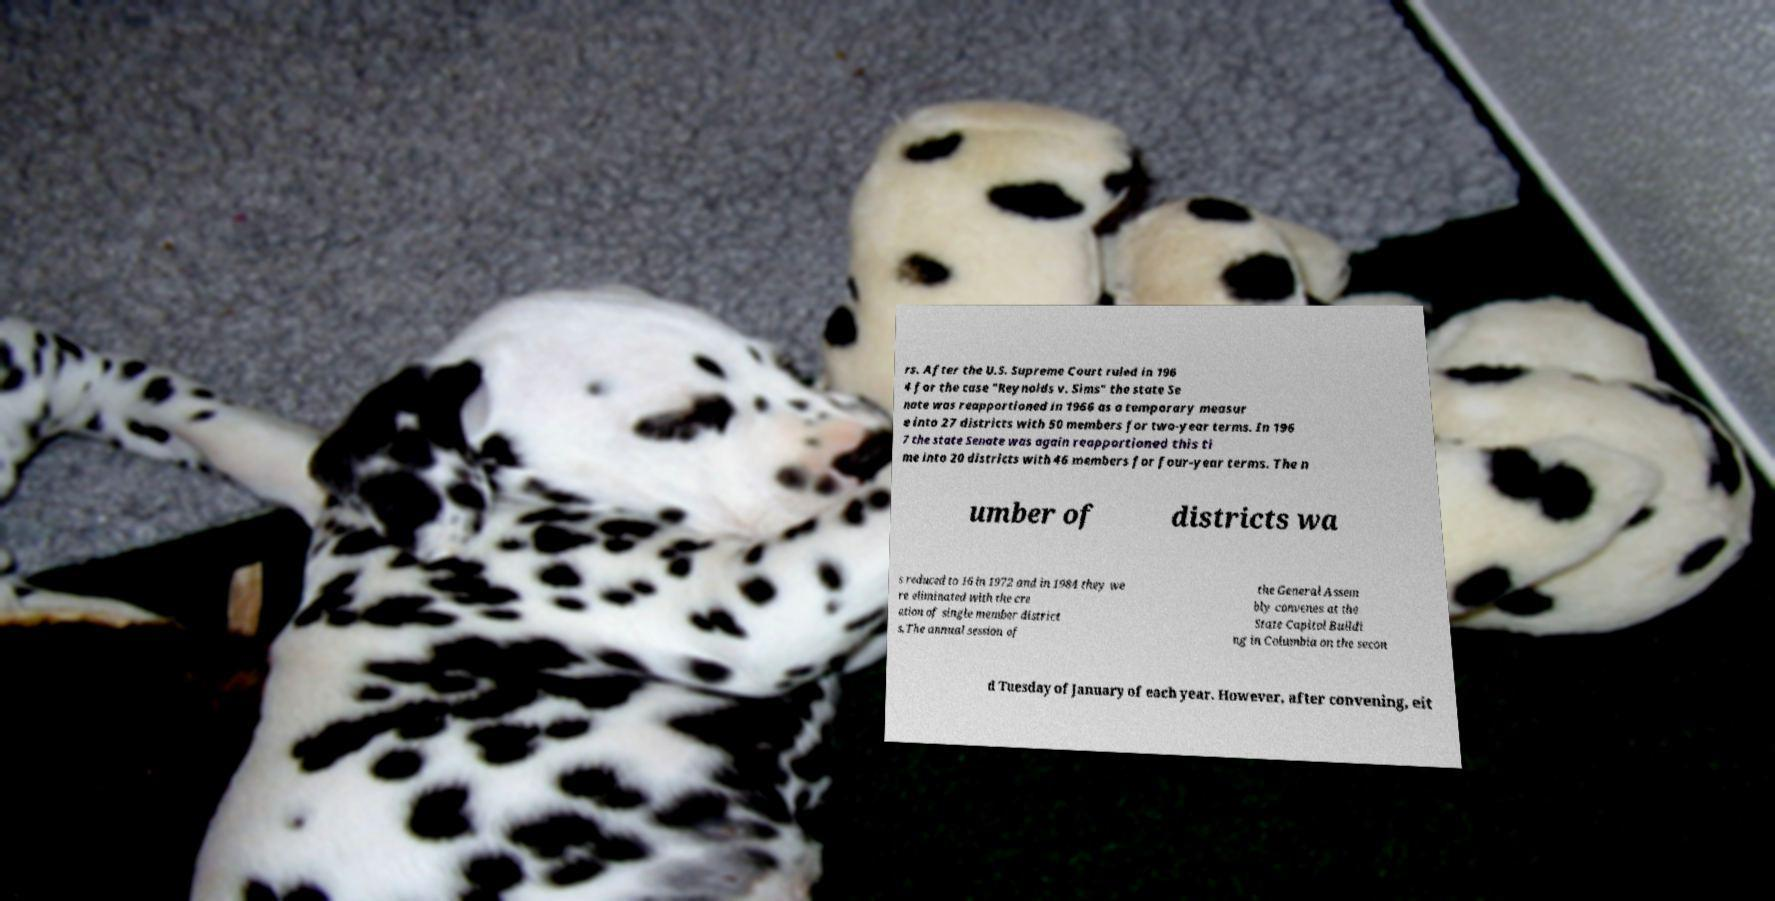Can you accurately transcribe the text from the provided image for me? rs. After the U.S. Supreme Court ruled in 196 4 for the case "Reynolds v. Sims" the state Se nate was reapportioned in 1966 as a temporary measur e into 27 districts with 50 members for two-year terms. In 196 7 the state Senate was again reapportioned this ti me into 20 districts with 46 members for four-year terms. The n umber of districts wa s reduced to 16 in 1972 and in 1984 they we re eliminated with the cre ation of single member district s.The annual session of the General Assem bly convenes at the State Capitol Buildi ng in Columbia on the secon d Tuesday of January of each year. However, after convening, eit 